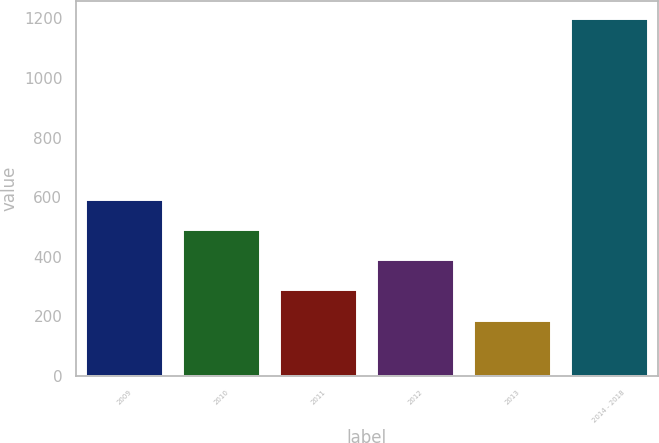Convert chart to OTSL. <chart><loc_0><loc_0><loc_500><loc_500><bar_chart><fcel>2009<fcel>2010<fcel>2011<fcel>2012<fcel>2013<fcel>2014 - 2018<nl><fcel>593.4<fcel>492.3<fcel>290.1<fcel>391.2<fcel>189<fcel>1200<nl></chart> 